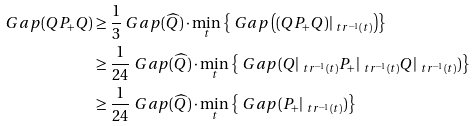<formula> <loc_0><loc_0><loc_500><loc_500>\ G a p ( Q P _ { + } Q ) & \geq \frac { 1 } { 3 } \ G a p ( \widehat { Q } ) \cdot \min _ { t } \left \{ \ G a p \left ( ( Q P _ { + } Q ) | _ { \ t r ^ { - 1 } ( t ) } \right ) \right \} \\ & \geq \frac { 1 } { 2 4 } \ G a p ( \widehat { Q } ) \cdot \min _ { t } \left \{ \ G a p ( Q | _ { \ t r ^ { - 1 } ( t ) } P _ { + } | _ { \ t r ^ { - 1 } ( t ) } Q | _ { \ t r ^ { - 1 } ( t ) } ) \right \} \\ & \geq \frac { 1 } { 2 4 } \ G a p ( \widehat { Q } ) \cdot \min _ { t } \left \{ \ G a p ( P _ { + } | _ { \ t r ^ { - 1 } ( t ) } ) \right \}</formula> 